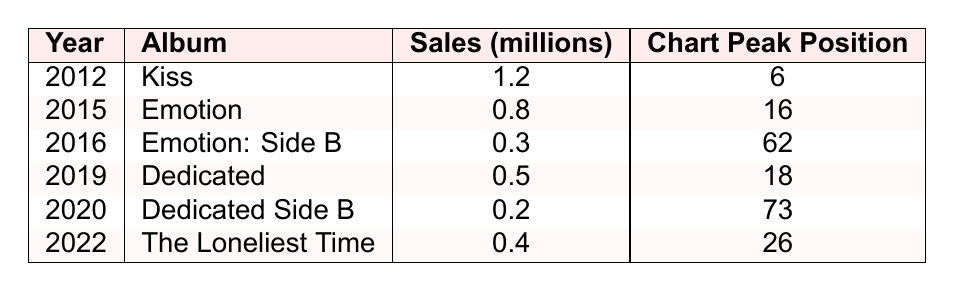What was the highest album sales in millions? The table shows the album sales for each year. The highest sales are for "Kiss" in 2012 with 1.2 million.
Answer: 1.2 million Which album had the lowest sales? Looking through the sales figures, "Dedicated Side B" had the lowest sales with 0.2 million.
Answer: 0.2 million How many albums did Carly Rae Jepsen release between 2015 and 2020? Counting the albums listed in the years between 2015 and 2020: "Emotion" (2015), "Emotion: Side B" (2016), "Dedicated" (2019), and "Dedicated Side B" (2020), there are four albums.
Answer: 4 What is the total sales of all albums listed in the table? Adding the sales figures: 1.2 + 0.8 + 0.3 + 0.5 + 0.2 + 0.4 = 3.4 million.
Answer: 3.4 million Did any album achieve a chart peak position higher than 10? The chart positions are listed in the table; only "Kiss" reached a position of 6, which is higher than 10. Therefore, the answer is no.
Answer: No What is the average sales (in millions) of Carly Rae Jepsen's albums from 2012 to 2022? To find the average, calculate the total sales (3.4 million) and divide it by the number of albums (6): 3.4 / 6 = 0.5667 million.
Answer: 0.57 million Which album released in 2019 had higher sales than the album released in 2020? The album "Dedicated" was released in 2019 with sales of 0.5 million, which is greater than "Dedicated Side B" released in 2020 with 0.2 million.
Answer: Yes What is the difference in sales between "Kiss" and "Emotion"? The sales for "Kiss" are 1.2 million and for "Emotion" they are 0.8 million. The difference is 1.2 - 0.8 = 0.4 million.
Answer: 0.4 million 